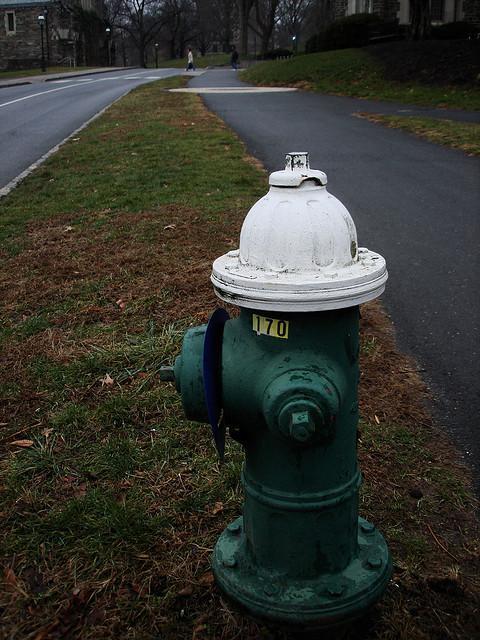How many chains are on the fire hydrant?
Give a very brief answer. 0. 